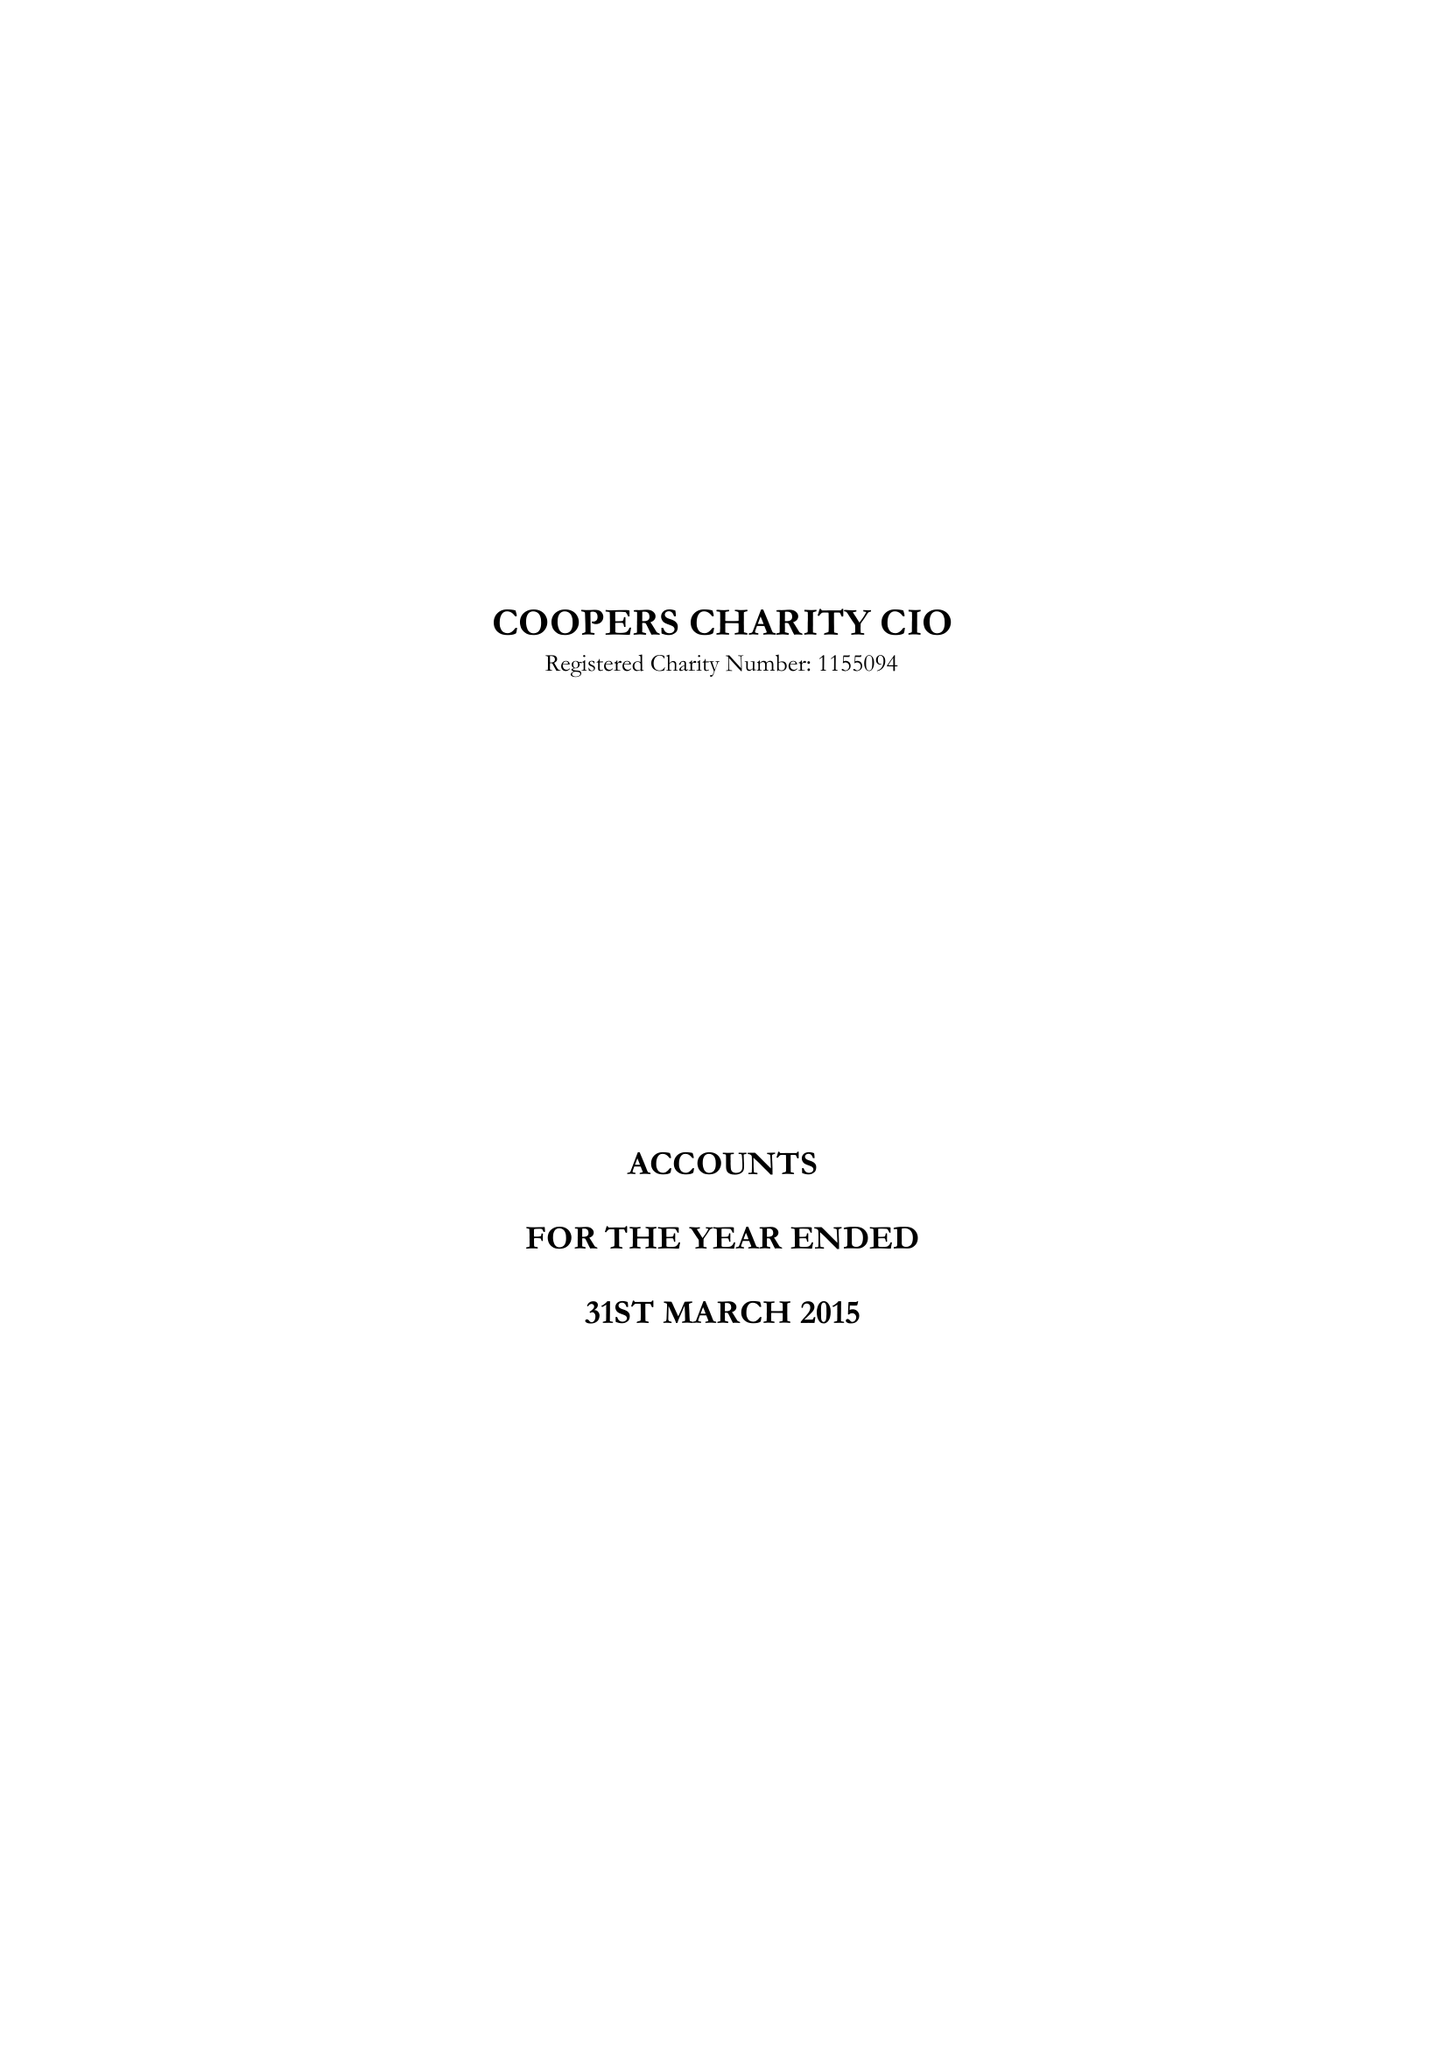What is the value for the charity_number?
Answer the question using a single word or phrase. 1155094 